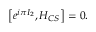Convert formula to latex. <formula><loc_0><loc_0><loc_500><loc_500>\left [ e ^ { i \pi I _ { 2 } } , H _ { C S } \right ] = 0 .</formula> 